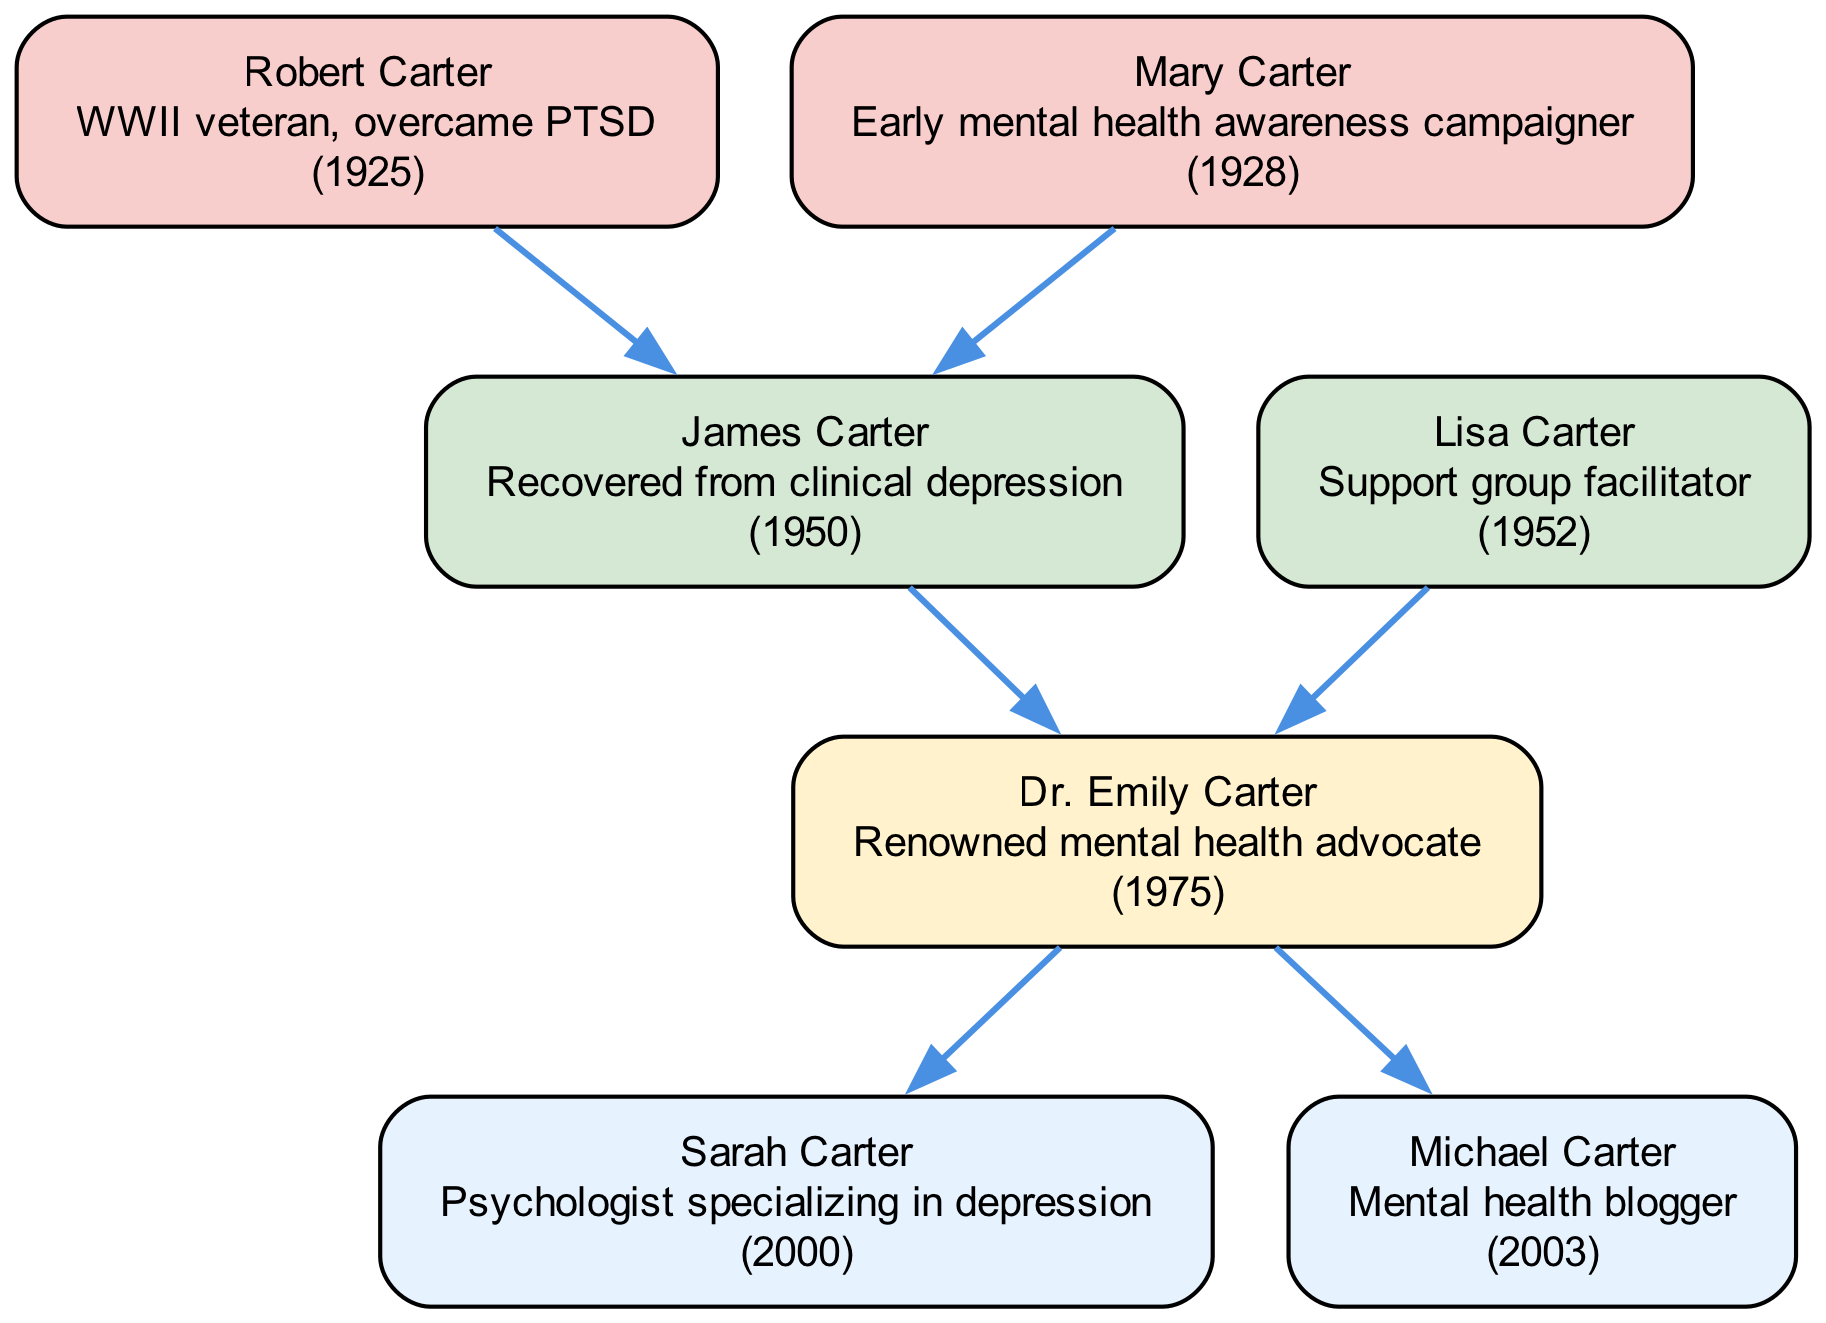What is the name of the root individual in the family tree? The root individual, represented at the top of the family tree, is Dr. Emily Carter.
Answer: Dr. Emily Carter How many children does Dr. Emily Carter have? By counting the nodes connected to Dr. Emily Carter that represent individuals in the "children" category, we see there are two children: Sarah Carter and Michael Carter.
Answer: 2 Who is the father of Dr. Emily Carter? The parent node connected to Dr. Emily Carter that represents the father is James Carter.
Answer: James Carter What year was Robert Carter born? Looking at the grandparent node for Robert Carter, the birth year is explicitly stated as 1925.
Answer: 1925 What is the profession of Sarah Carter? The description associated with Sarah Carter indicates she is a psychologist specializing in depression.
Answer: Psychologist specializing in depression Which individual has a connection to both Dr. Emily Carter and James Carter? The individual that connects both Dr. Emily Carter and James Carter is Lisa Carter, as she is Dr. Emily’s mother and James Carter's spouse.
Answer: Lisa Carter What relationship did Robert Carter have with Dr. Emily Carter? Robert Carter is the grandfather of Dr. Emily Carter, as he is one of her parents' fathers.
Answer: Grandfather How many grandparents are represented in the diagram? The diagram shows two nodes labeled as grandparents, specifically Robert Carter and Mary Carter.
Answer: 2 Which individual is noted as a mental health blogger? The description associated with Michael Carter indicates that he is a mental health blogger.
Answer: Mental health blogger What is the primary advocacy focus of the root individual? As noted in the description of Dr. Emily Carter, her primary advocacy focus is mental health.
Answer: Mental health 